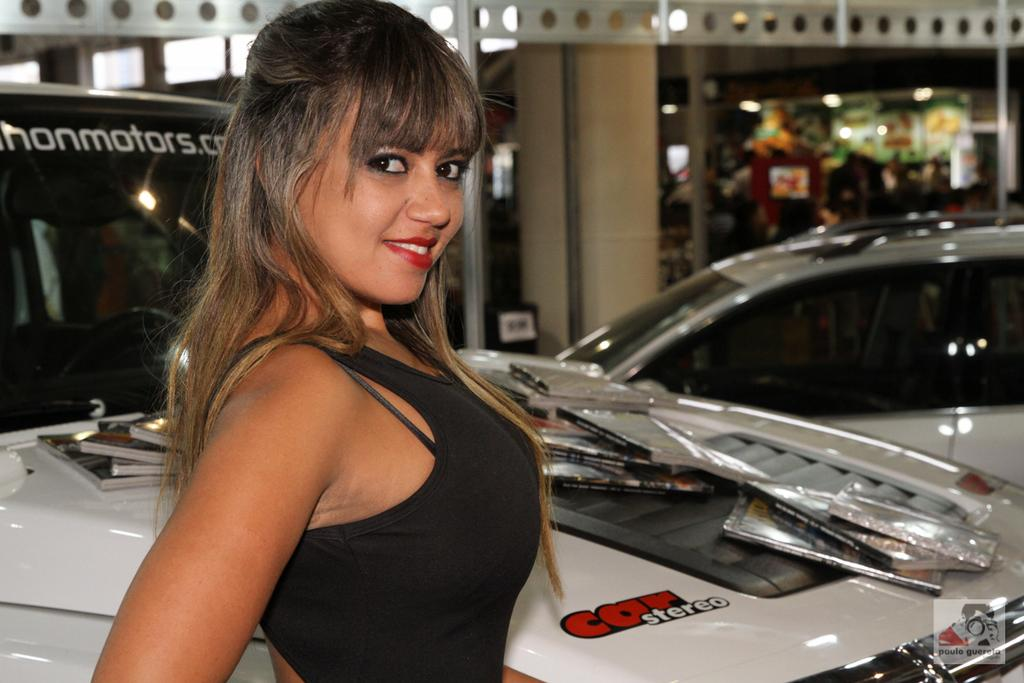Who is present in the image? There is a woman in the image. What is the woman's expression? The woman is smiling. What else can be seen in the image besides the woman? There are vehicles, objects on the vehicles, a blurry background, lights, a wall, and a rod in the background. What type of wool is being used to make the jewel in the image? There is no wool or jewel present in the image. What type of voyage is the woman embarking on in the image? There is no indication of a voyage in the image; it simply shows a woman smiling with vehicles in the background. 